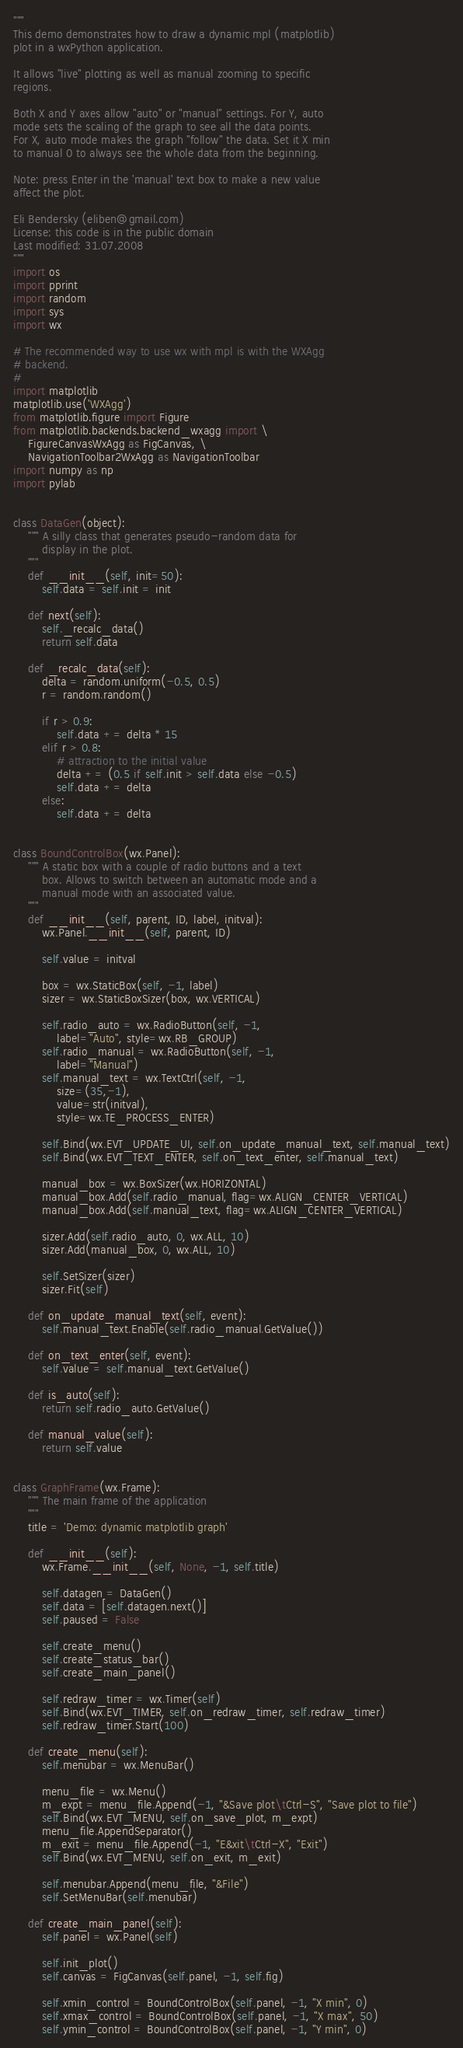<code> <loc_0><loc_0><loc_500><loc_500><_Python_>"""
This demo demonstrates how to draw a dynamic mpl (matplotlib) 
plot in a wxPython application.

It allows "live" plotting as well as manual zooming to specific
regions.

Both X and Y axes allow "auto" or "manual" settings. For Y, auto
mode sets the scaling of the graph to see all the data points.
For X, auto mode makes the graph "follow" the data. Set it X min
to manual 0 to always see the whole data from the beginning.

Note: press Enter in the 'manual' text box to make a new value 
affect the plot.

Eli Bendersky (eliben@gmail.com)
License: this code is in the public domain
Last modified: 31.07.2008
"""
import os
import pprint
import random
import sys
import wx

# The recommended way to use wx with mpl is with the WXAgg
# backend. 
#
import matplotlib
matplotlib.use('WXAgg')
from matplotlib.figure import Figure
from matplotlib.backends.backend_wxagg import \
    FigureCanvasWxAgg as FigCanvas, \
    NavigationToolbar2WxAgg as NavigationToolbar
import numpy as np
import pylab


class DataGen(object):
    """ A silly class that generates pseudo-random data for
        display in the plot.
    """
    def __init__(self, init=50):
        self.data = self.init = init
        
    def next(self):
        self._recalc_data()
        return self.data
    
    def _recalc_data(self):
        delta = random.uniform(-0.5, 0.5)
        r = random.random()

        if r > 0.9:
            self.data += delta * 15
        elif r > 0.8: 
            # attraction to the initial value
            delta += (0.5 if self.init > self.data else -0.5)
            self.data += delta
        else:
            self.data += delta


class BoundControlBox(wx.Panel):
    """ A static box with a couple of radio buttons and a text
        box. Allows to switch between an automatic mode and a 
        manual mode with an associated value.
    """
    def __init__(self, parent, ID, label, initval):
        wx.Panel.__init__(self, parent, ID)
        
        self.value = initval
        
        box = wx.StaticBox(self, -1, label)
        sizer = wx.StaticBoxSizer(box, wx.VERTICAL)
        
        self.radio_auto = wx.RadioButton(self, -1, 
            label="Auto", style=wx.RB_GROUP)
        self.radio_manual = wx.RadioButton(self, -1,
            label="Manual")
        self.manual_text = wx.TextCtrl(self, -1, 
            size=(35,-1),
            value=str(initval),
            style=wx.TE_PROCESS_ENTER)
        
        self.Bind(wx.EVT_UPDATE_UI, self.on_update_manual_text, self.manual_text)
        self.Bind(wx.EVT_TEXT_ENTER, self.on_text_enter, self.manual_text)
        
        manual_box = wx.BoxSizer(wx.HORIZONTAL)
        manual_box.Add(self.radio_manual, flag=wx.ALIGN_CENTER_VERTICAL)
        manual_box.Add(self.manual_text, flag=wx.ALIGN_CENTER_VERTICAL)
        
        sizer.Add(self.radio_auto, 0, wx.ALL, 10)
        sizer.Add(manual_box, 0, wx.ALL, 10)
        
        self.SetSizer(sizer)
        sizer.Fit(self)
    
    def on_update_manual_text(self, event):
        self.manual_text.Enable(self.radio_manual.GetValue())
    
    def on_text_enter(self, event):
        self.value = self.manual_text.GetValue()
    
    def is_auto(self):
        return self.radio_auto.GetValue()
        
    def manual_value(self):
        return self.value


class GraphFrame(wx.Frame):
    """ The main frame of the application
    """
    title = 'Demo: dynamic matplotlib graph'
    
    def __init__(self):
        wx.Frame.__init__(self, None, -1, self.title)
        
        self.datagen = DataGen()
        self.data = [self.datagen.next()]
        self.paused = False
        
        self.create_menu()
        self.create_status_bar()
        self.create_main_panel()
        
        self.redraw_timer = wx.Timer(self)
        self.Bind(wx.EVT_TIMER, self.on_redraw_timer, self.redraw_timer)        
        self.redraw_timer.Start(100)

    def create_menu(self):
        self.menubar = wx.MenuBar()
        
        menu_file = wx.Menu()
        m_expt = menu_file.Append(-1, "&Save plot\tCtrl-S", "Save plot to file")
        self.Bind(wx.EVT_MENU, self.on_save_plot, m_expt)
        menu_file.AppendSeparator()
        m_exit = menu_file.Append(-1, "E&xit\tCtrl-X", "Exit")
        self.Bind(wx.EVT_MENU, self.on_exit, m_exit)
                
        self.menubar.Append(menu_file, "&File")
        self.SetMenuBar(self.menubar)

    def create_main_panel(self):
        self.panel = wx.Panel(self)

        self.init_plot()
        self.canvas = FigCanvas(self.panel, -1, self.fig)

        self.xmin_control = BoundControlBox(self.panel, -1, "X min", 0)
        self.xmax_control = BoundControlBox(self.panel, -1, "X max", 50)
        self.ymin_control = BoundControlBox(self.panel, -1, "Y min", 0)</code> 